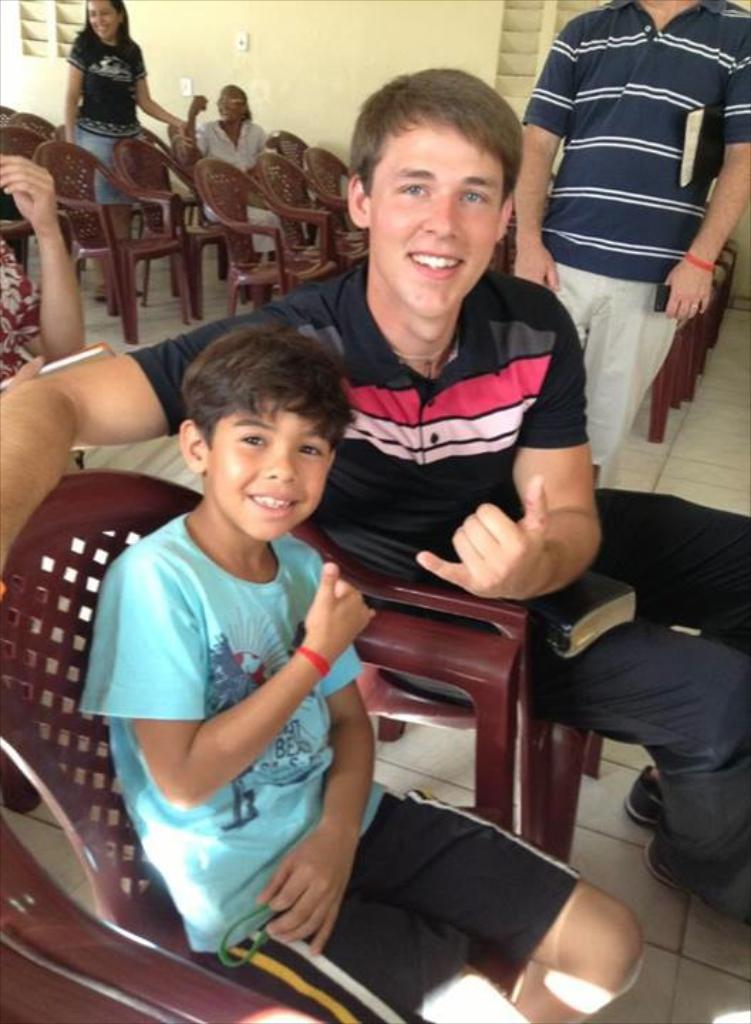How many boys are sitting in chairs in the image? There are two boys sitting in chairs in the image. What expression do the boys have in the image? The boys are smiling in the image. Are there any other chairs visible in the image? Yes, there are additional chairs behind the boys. What is the gender of the person standing near the boys? There is a girl standing near the boys in the image. What can be seen in the background of the image? There is a wall visible in the image. What type of cake is being shared by the boys during the rainstorm in the image? There is no cake or rainstorm present in the image; it features two boys sitting in chairs and a girl standing nearby. 